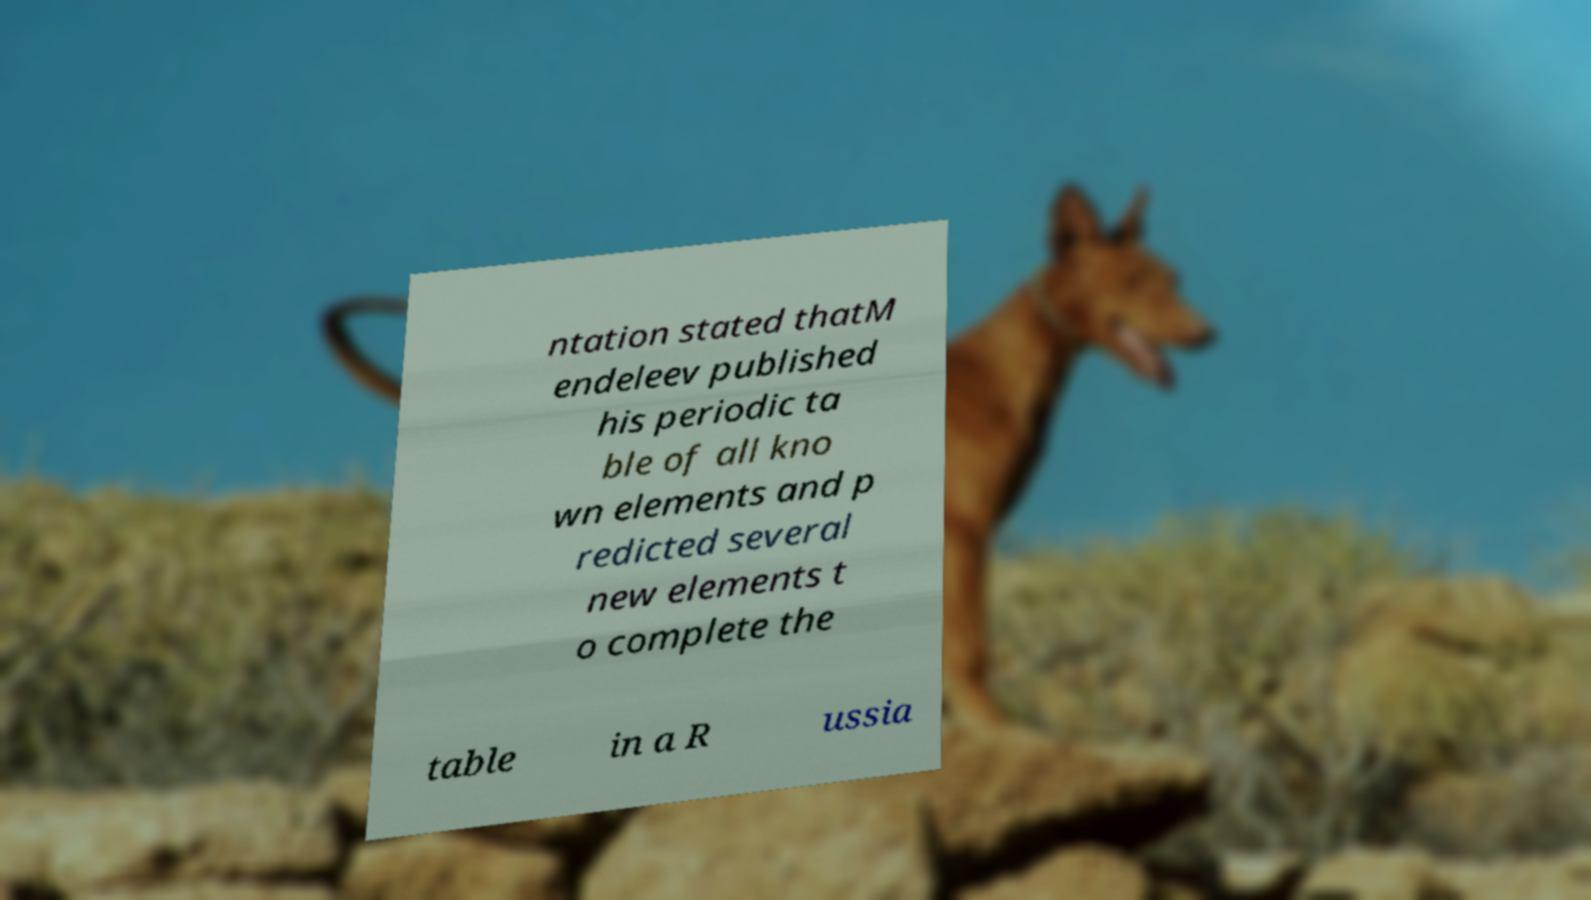Please identify and transcribe the text found in this image. ntation stated thatM endeleev published his periodic ta ble of all kno wn elements and p redicted several new elements t o complete the table in a R ussia 